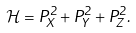Convert formula to latex. <formula><loc_0><loc_0><loc_500><loc_500>\mathcal { H } = P _ { X } ^ { 2 } + P _ { Y } ^ { 2 } + P _ { Z } ^ { 2 } .</formula> 